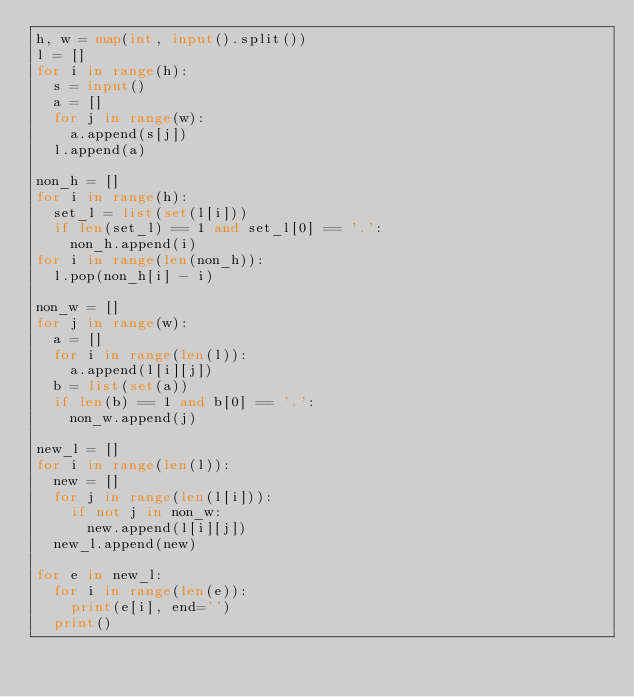<code> <loc_0><loc_0><loc_500><loc_500><_Python_>h, w = map(int, input().split())
l = []
for i in range(h):
  s = input()
  a = []
  for j in range(w):
    a.append(s[j])
  l.append(a)

non_h = []
for i in range(h):
  set_l = list(set(l[i]))
  if len(set_l) == 1 and set_l[0] == '.':
    non_h.append(i)
for i in range(len(non_h)):
  l.pop(non_h[i] - i)

non_w = []
for j in range(w):
  a = []
  for i in range(len(l)):
    a.append(l[i][j])
  b = list(set(a))
  if len(b) == 1 and b[0] == '.':
    non_w.append(j)

new_l = []
for i in range(len(l)):
  new = []
  for j in range(len(l[i])):
    if not j in non_w:
      new.append(l[i][j])
  new_l.append(new)

for e in new_l:
  for i in range(len(e)):
    print(e[i], end='')
  print()</code> 